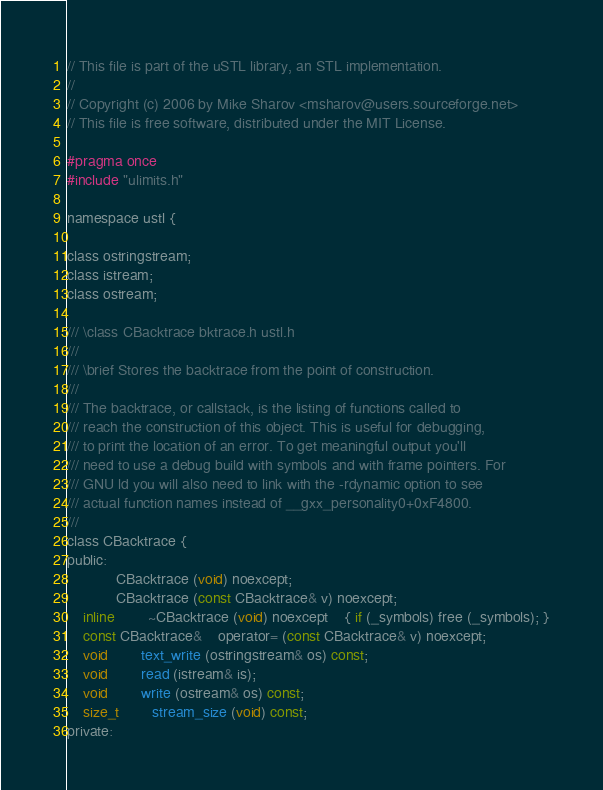Convert code to text. <code><loc_0><loc_0><loc_500><loc_500><_C_>// This file is part of the uSTL library, an STL implementation.
//
// Copyright (c) 2006 by Mike Sharov <msharov@users.sourceforge.net>
// This file is free software, distributed under the MIT License.

#pragma once
#include "ulimits.h"

namespace ustl {

class ostringstream;
class istream;
class ostream;

/// \class CBacktrace bktrace.h ustl.h
///
/// \brief Stores the backtrace from the point of construction.
///
/// The backtrace, or callstack, is the listing of functions called to
/// reach the construction of this object. This is useful for debugging,
/// to print the location of an error. To get meaningful output you'll
/// need to use a debug build with symbols and with frame pointers. For
/// GNU ld you will also need to link with the -rdynamic option to see
/// actual function names instead of __gxx_personality0+0xF4800.
///
class CBacktrace {
public:
			CBacktrace (void) noexcept;
			CBacktrace (const CBacktrace& v) noexcept;
    inline		~CBacktrace (void) noexcept	{ if (_symbols) free (_symbols); }
    const CBacktrace&	operator= (const CBacktrace& v) noexcept;
    void		text_write (ostringstream& os) const;
    void		read (istream& is);
    void		write (ostream& os) const;
    size_t		stream_size (void) const;
private:</code> 